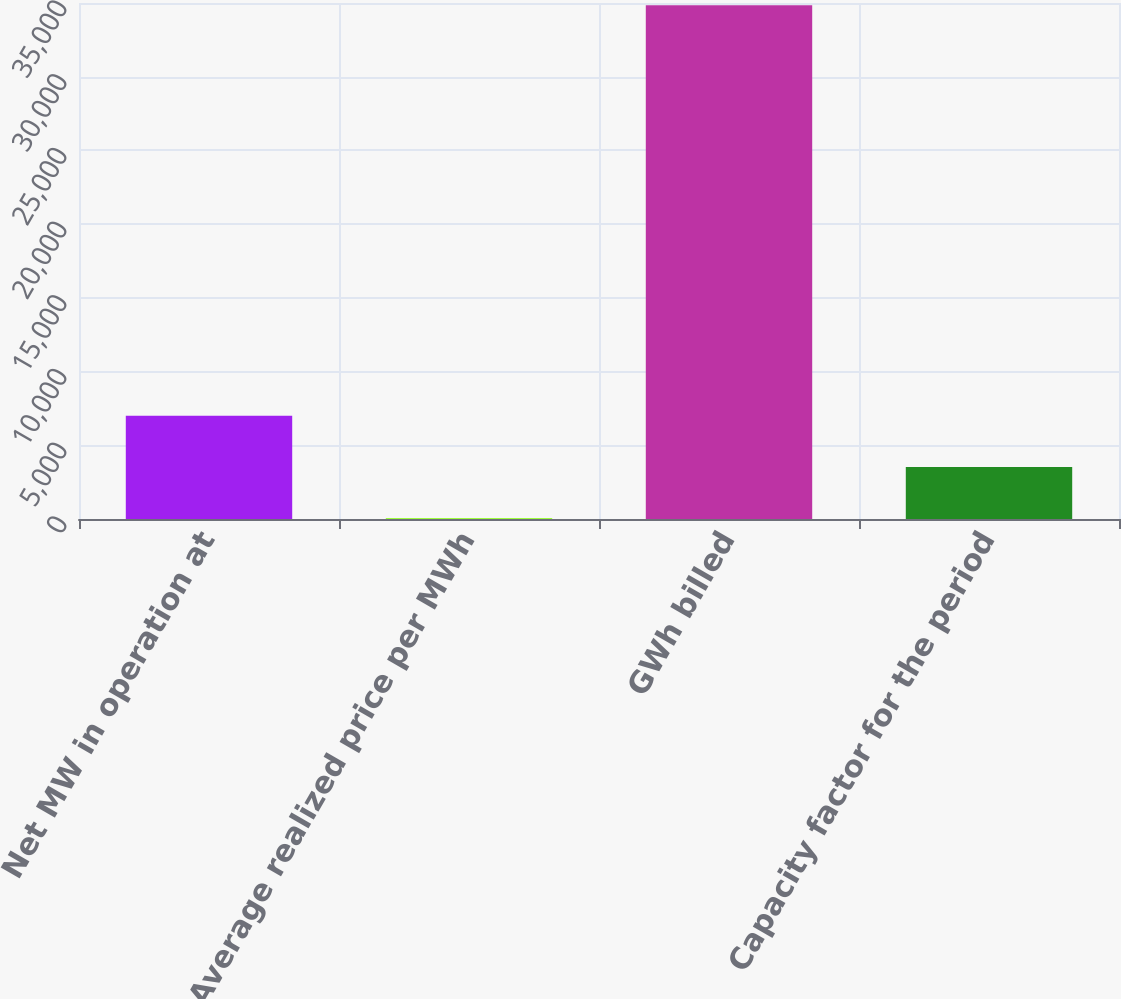Convert chart to OTSL. <chart><loc_0><loc_0><loc_500><loc_500><bar_chart><fcel>Net MW in operation at<fcel>Average realized price per MWh<fcel>GWh billed<fcel>Capacity factor for the period<nl><fcel>7004.87<fcel>44.33<fcel>34847<fcel>3524.6<nl></chart> 